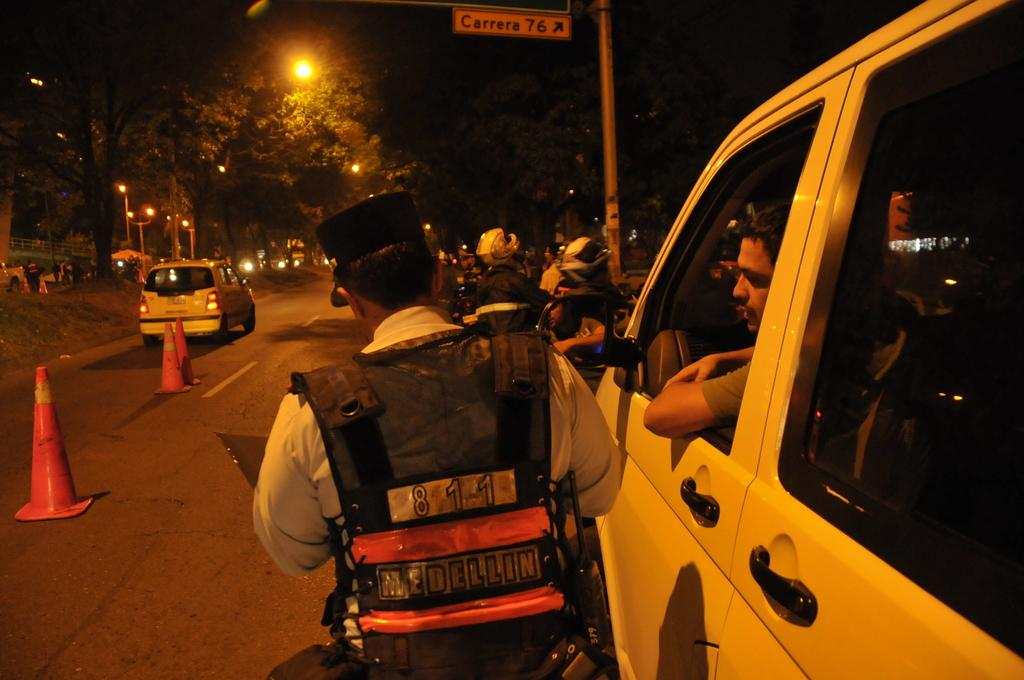<image>
Relay a brief, clear account of the picture shown. A person in a white car is talking to a police officer who has 811 Medellin on his vest. 